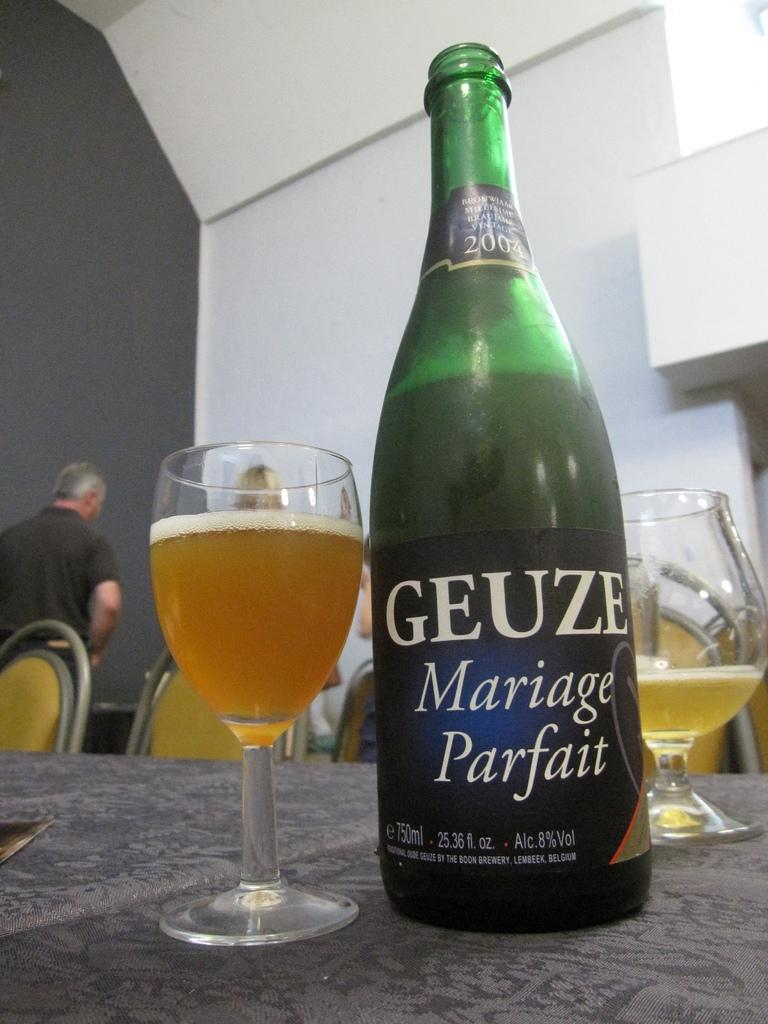What is in the bottle that is visible in the image? There is a bottle of champagne in the image. What are the glasses filled with in the image? The glasses are filled with champagne in the image. Where are the bottle and glasses placed in the image? The bottle and glasses are placed on a table in the image. What type of furniture is visible in the image? There are chairs visible in the image. Who is present in the image? There is a person present in the image. What type of oil can be seen dripping from the goose in the image? There is no goose or oil present in the image. 